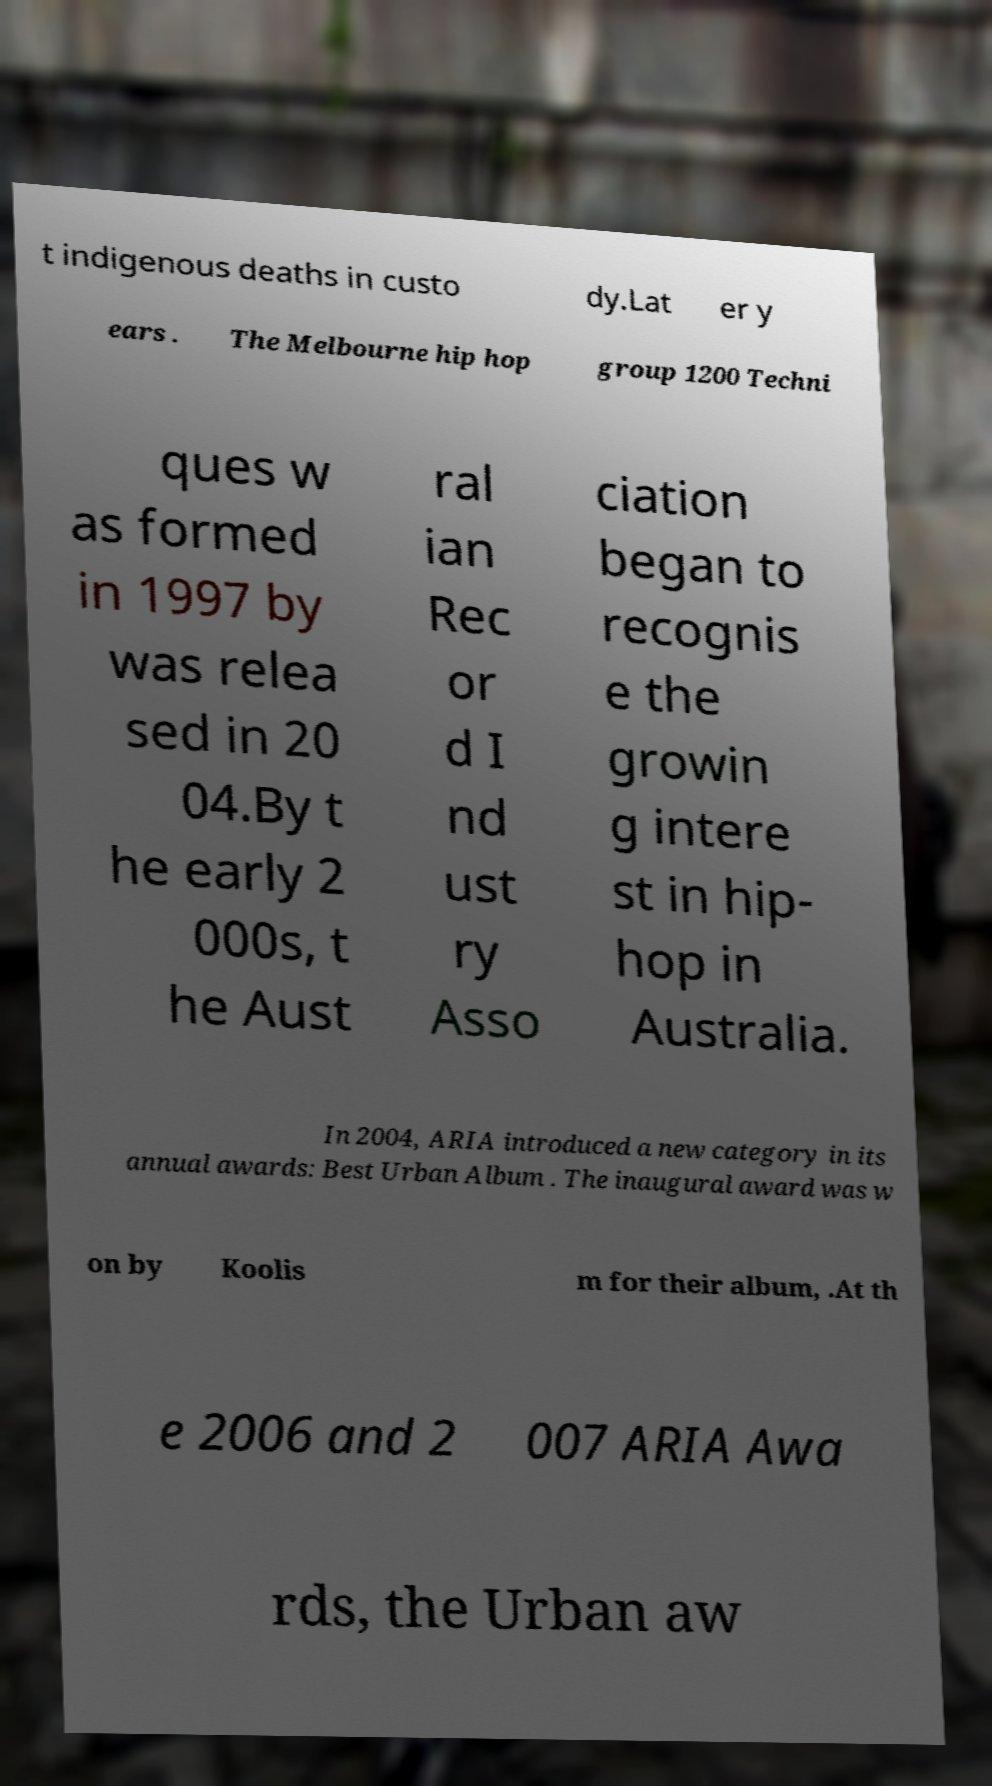What messages or text are displayed in this image? I need them in a readable, typed format. t indigenous deaths in custo dy.Lat er y ears . The Melbourne hip hop group 1200 Techni ques w as formed in 1997 by was relea sed in 20 04.By t he early 2 000s, t he Aust ral ian Rec or d I nd ust ry Asso ciation began to recognis e the growin g intere st in hip- hop in Australia. In 2004, ARIA introduced a new category in its annual awards: Best Urban Album . The inaugural award was w on by Koolis m for their album, .At th e 2006 and 2 007 ARIA Awa rds, the Urban aw 